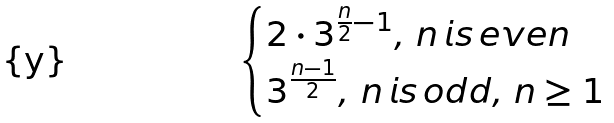<formula> <loc_0><loc_0><loc_500><loc_500>\begin{cases} 2 \cdot 3 ^ { \frac { n } { 2 } - 1 } , \, n \, i s \, e v e n \\ 3 ^ { \frac { n - 1 } { 2 } } , \, n \, i s \, o d d , \, n \geq 1 \end{cases}</formula> 